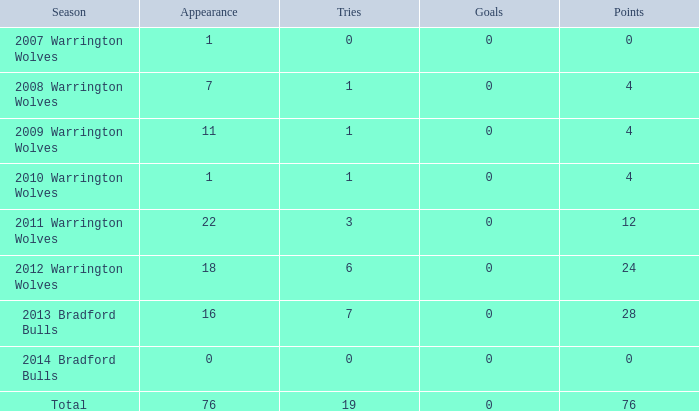What is the mean attempts for the 2008 warrington wolves season with over 7 appearances? None. 